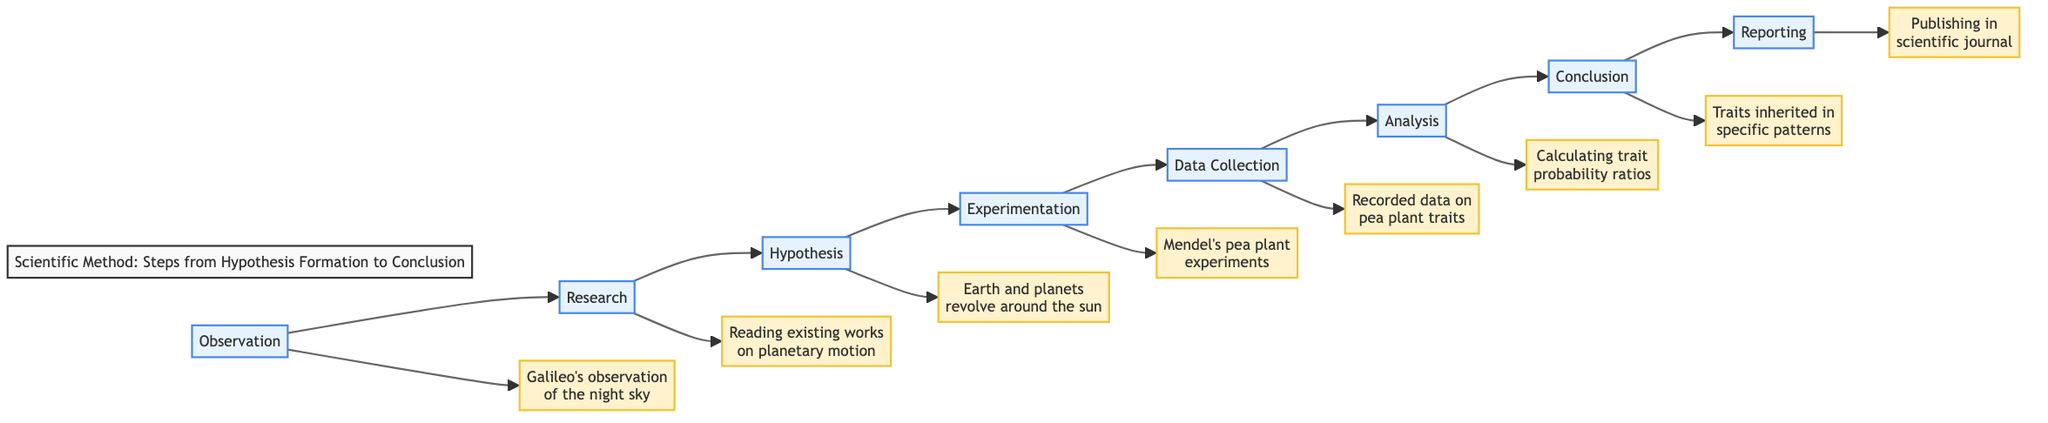What is the first step in the scientific method? The diagram shows that the first step is "Observation." This is visually represented as the leftmost node in the flowchart.
Answer: Observation How many steps are there in the scientific method according to the diagram? By counting the nodes listed in the diagram, there are a total of eight steps present in the scientific method flowchart.
Answer: Eight What example is given for the 'Experimentation' step? The diagram provides "Mendel's pea plant experiments" as the example for the 'Experimentation' step, which is indicated in the flowchart.
Answer: Mendel's pea plant experiments What connects 'Hypothesis' to 'Experimentation'? The flowchart shows a direct connection or arrow from 'Hypothesis' to 'Experimentation,' indicating the progression between these two steps.
Answer: Arrow In which step did Gregor Mendel analyze the data? Based on the diagram, Gregor Mendel analyzed the data during the 'Analysis' step, which comes after 'Data Collection.'
Answer: Analysis What does the 'Conclusion' step determine regarding the hypothesis? The 'Conclusion' step determines if the hypothesis is supported or refuted, as stated next to that step in the diagram.
Answer: Supported or refuted What is one historical contribution listed in the diagram? The flowchart includes "Supported the heliocentric model by showing moons orbiting Jupiter" as a contribution associated with Galileo's telescope observations.
Answer: Supported the heliocentric model What comes directly after 'Data Collection'? According to the flowchart, 'Analysis' comes directly after 'Data Collection,' indicating the sequence of steps in the scientific method.
Answer: Analysis How does 'Reporting' relate to the scientific community? The diagram states that 'Reporting' involves sharing results with the scientific community, which is the final step in the flowchart.
Answer: Sharing results 